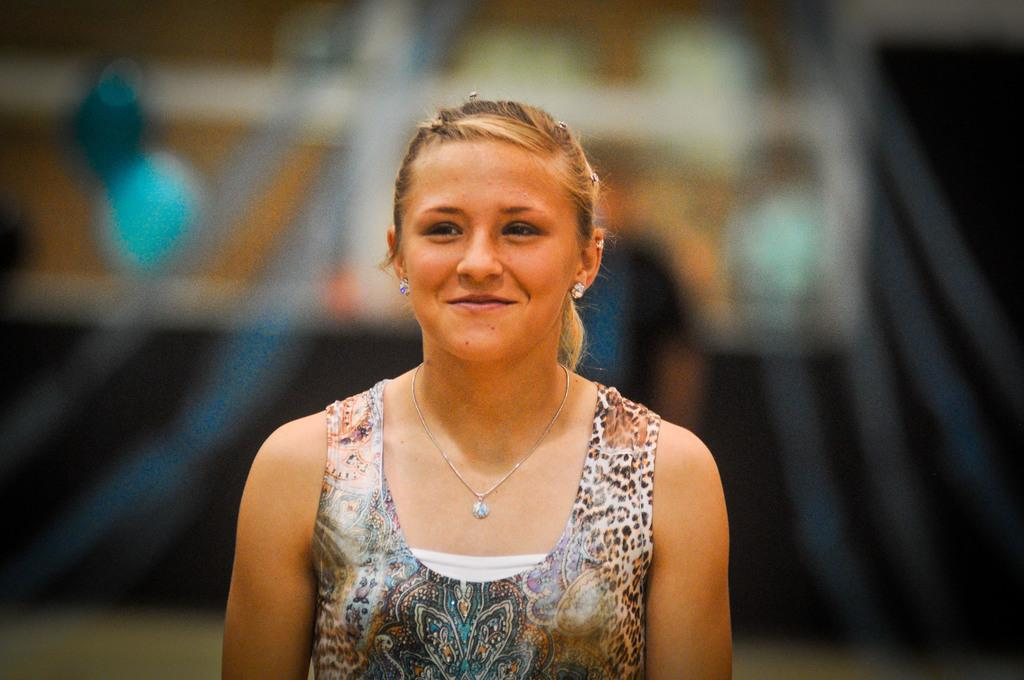Who is the main subject in the image? There is a woman in the image. What is the woman doing in the image? The woman is smiling. What accessory is the woman wearing in the image? The woman is wearing a necklace. What is the woman wearing besides the necklace? The woman is wearing clothes. Can you describe the background of the image? The background of the image is blurred. What type of mint is growing in the background of the image? There is no mint present in the image; the background is blurred. 